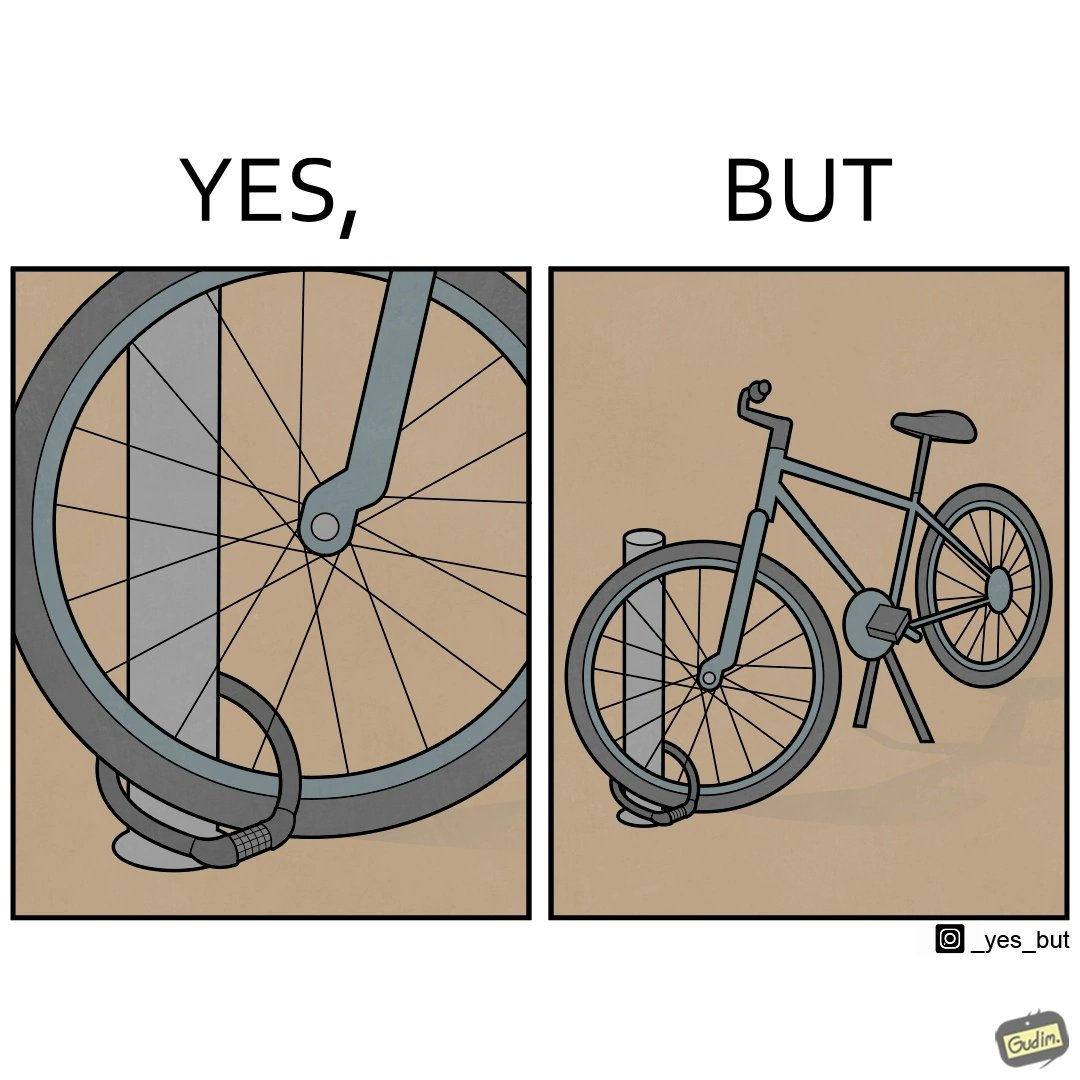Does this image contain satire or humor? Yes, this image is satirical. 